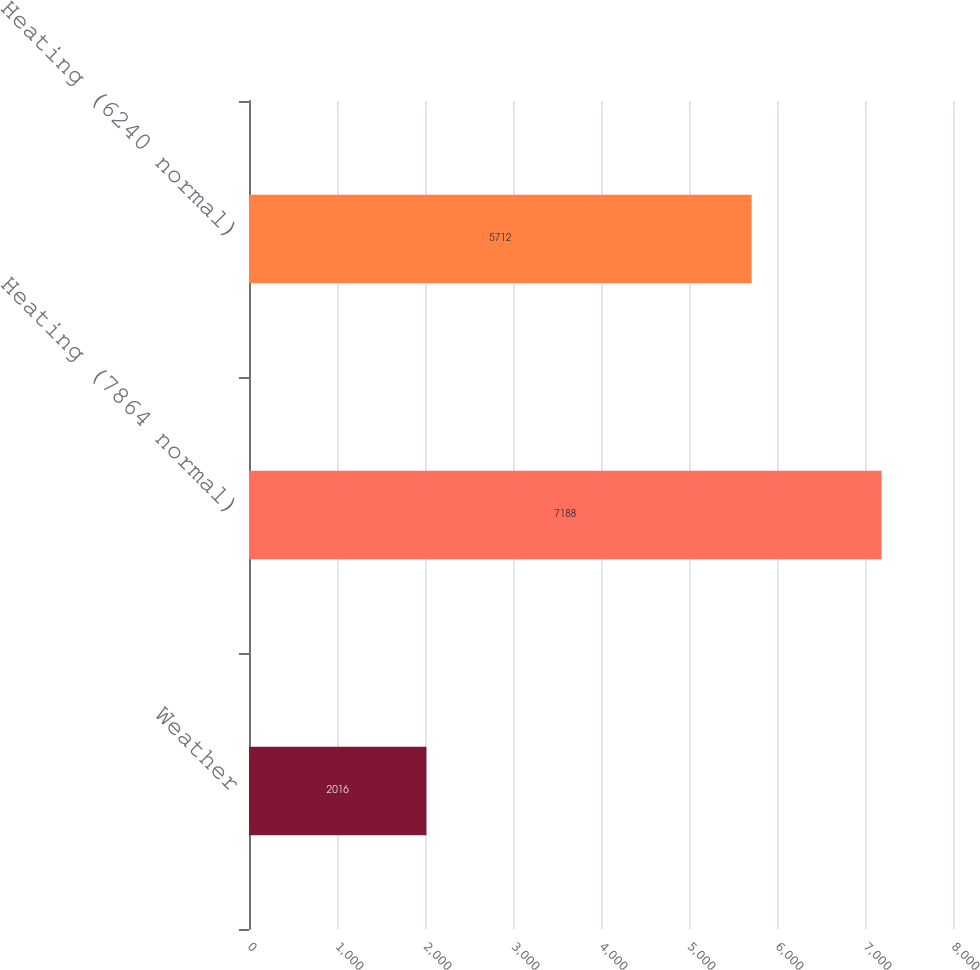Convert chart to OTSL. <chart><loc_0><loc_0><loc_500><loc_500><bar_chart><fcel>Weather<fcel>Heating (7864 normal)<fcel>Heating (6240 normal)<nl><fcel>2016<fcel>7188<fcel>5712<nl></chart> 